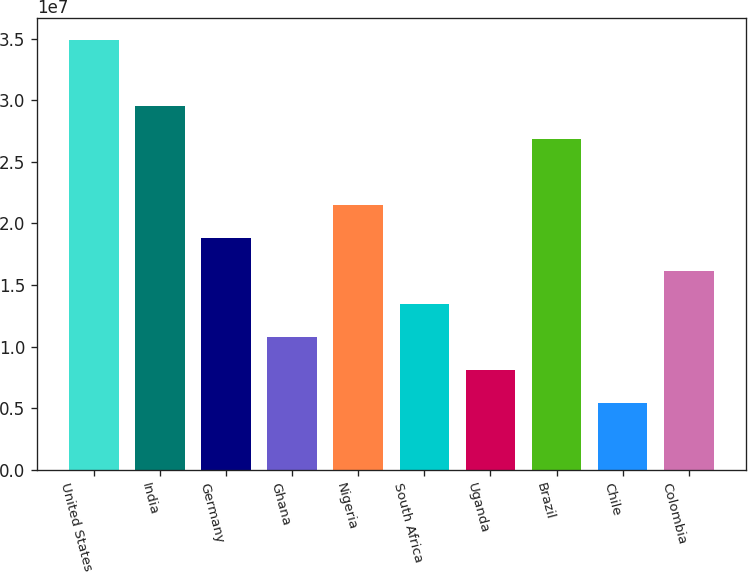Convert chart to OTSL. <chart><loc_0><loc_0><loc_500><loc_500><bar_chart><fcel>United States<fcel>India<fcel>Germany<fcel>Ghana<fcel>Nigeria<fcel>South Africa<fcel>Uganda<fcel>Brazil<fcel>Chile<fcel>Colombia<nl><fcel>3.49013e+07<fcel>2.95421e+07<fcel>1.88238e+07<fcel>1.0785e+07<fcel>2.15034e+07<fcel>1.34646e+07<fcel>8.10538e+06<fcel>2.68625e+07<fcel>5.42578e+06<fcel>1.61442e+07<nl></chart> 